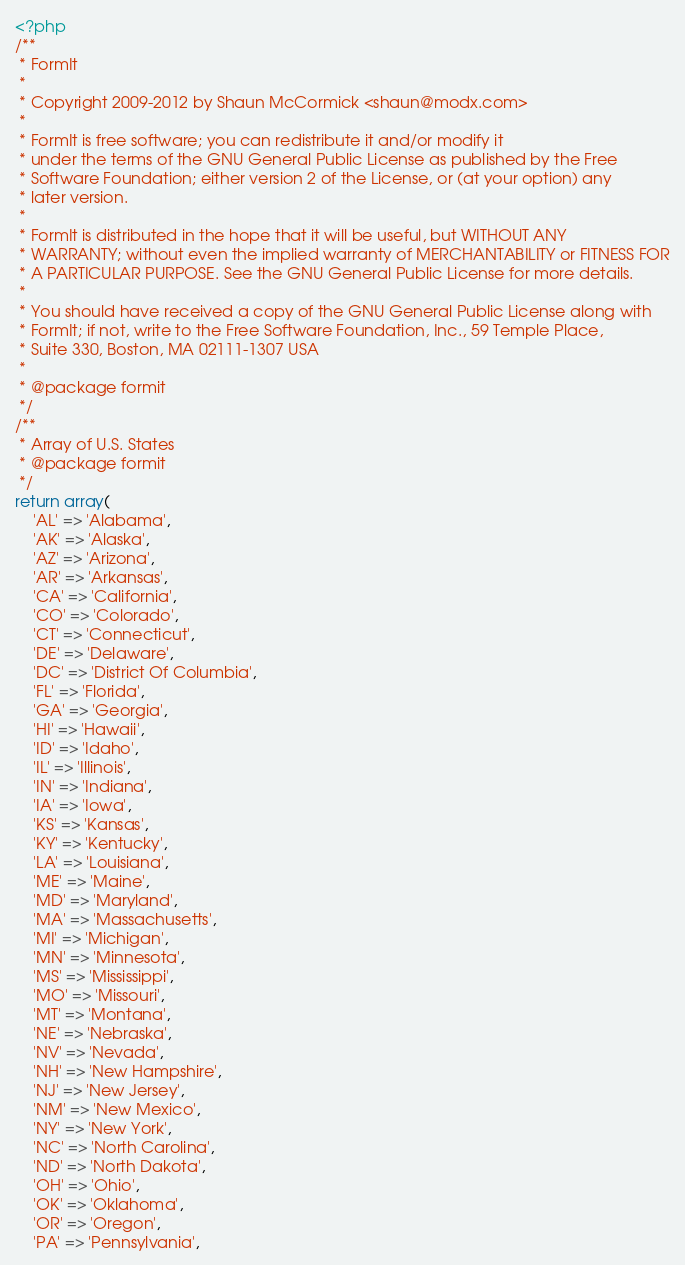Convert code to text. <code><loc_0><loc_0><loc_500><loc_500><_PHP_><?php
/**
 * FormIt
 *
 * Copyright 2009-2012 by Shaun McCormick <shaun@modx.com>
 *
 * FormIt is free software; you can redistribute it and/or modify it
 * under the terms of the GNU General Public License as published by the Free
 * Software Foundation; either version 2 of the License, or (at your option) any
 * later version.
 *
 * FormIt is distributed in the hope that it will be useful, but WITHOUT ANY
 * WARRANTY; without even the implied warranty of MERCHANTABILITY or FITNESS FOR
 * A PARTICULAR PURPOSE. See the GNU General Public License for more details.
 *
 * You should have received a copy of the GNU General Public License along with
 * FormIt; if not, write to the Free Software Foundation, Inc., 59 Temple Place,
 * Suite 330, Boston, MA 02111-1307 USA
 *
 * @package formit
 */
/**
 * Array of U.S. States
 * @package formit
 */
return array(
    'AL' => 'Alabama',
    'AK' => 'Alaska',
    'AZ' => 'Arizona',
    'AR' => 'Arkansas',
    'CA' => 'California',
    'CO' => 'Colorado',
    'CT' => 'Connecticut',
    'DE' => 'Delaware',
    'DC' => 'District Of Columbia',
    'FL' => 'Florida',
    'GA' => 'Georgia',
    'HI' => 'Hawaii',
    'ID' => 'Idaho',
    'IL' => 'Illinois',
    'IN' => 'Indiana',
    'IA' => 'Iowa',
    'KS' => 'Kansas',
    'KY' => 'Kentucky',
    'LA' => 'Louisiana',
    'ME' => 'Maine',
    'MD' => 'Maryland',
    'MA' => 'Massachusetts',
    'MI' => 'Michigan',
    'MN' => 'Minnesota',
    'MS' => 'Mississippi',
    'MO' => 'Missouri',
    'MT' => 'Montana',
    'NE' => 'Nebraska',
    'NV' => 'Nevada',
    'NH' => 'New Hampshire',
    'NJ' => 'New Jersey',
    'NM' => 'New Mexico',
    'NY' => 'New York',
    'NC' => 'North Carolina',
    'ND' => 'North Dakota',
    'OH' => 'Ohio',
    'OK' => 'Oklahoma',
    'OR' => 'Oregon',
    'PA' => 'Pennsylvania',</code> 